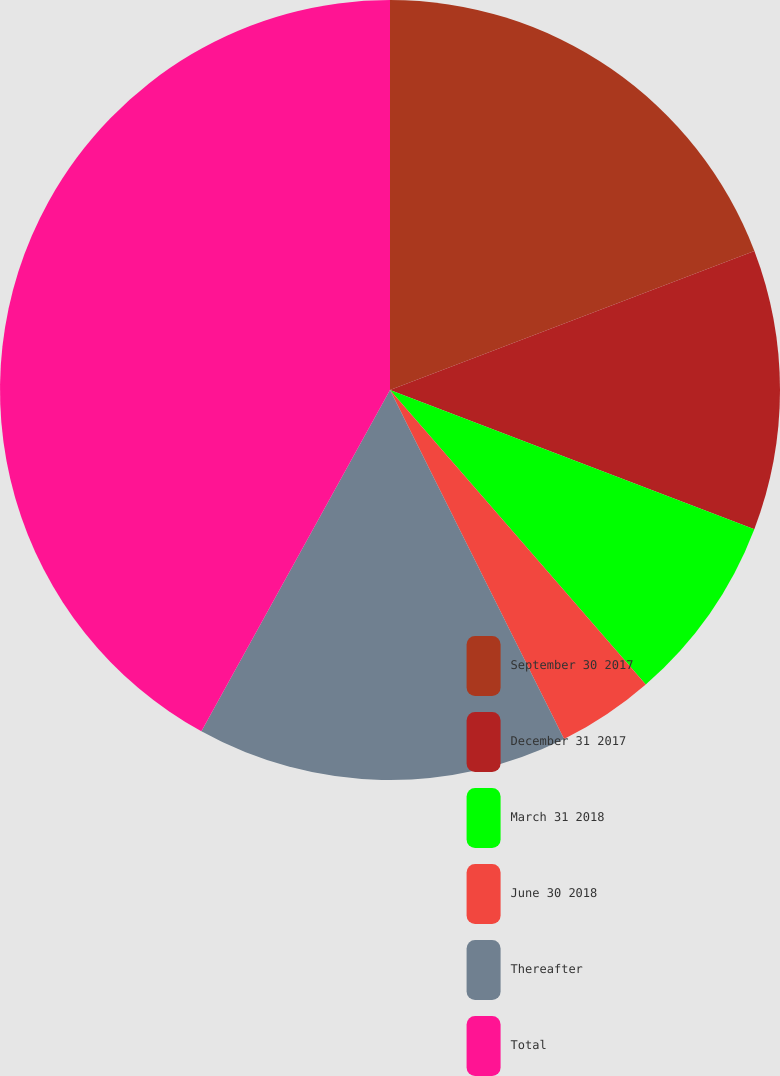Convert chart to OTSL. <chart><loc_0><loc_0><loc_500><loc_500><pie_chart><fcel>September 30 2017<fcel>December 31 2017<fcel>March 31 2018<fcel>June 30 2018<fcel>Thereafter<fcel>Total<nl><fcel>19.2%<fcel>11.61%<fcel>7.81%<fcel>4.02%<fcel>15.4%<fcel>41.97%<nl></chart> 